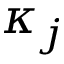Convert formula to latex. <formula><loc_0><loc_0><loc_500><loc_500>\kappa _ { j }</formula> 